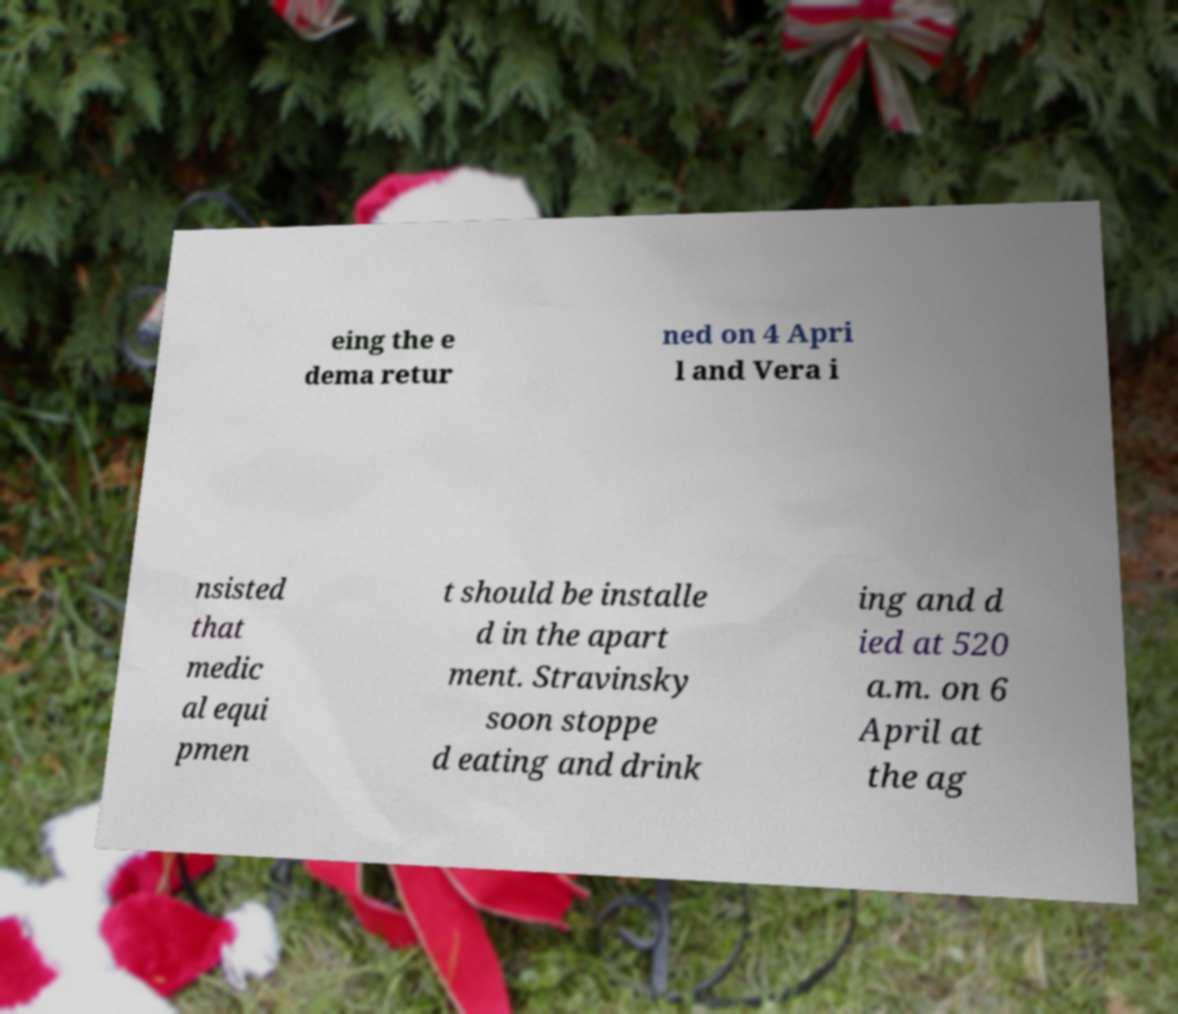Could you extract and type out the text from this image? eing the e dema retur ned on 4 Apri l and Vera i nsisted that medic al equi pmen t should be installe d in the apart ment. Stravinsky soon stoppe d eating and drink ing and d ied at 520 a.m. on 6 April at the ag 